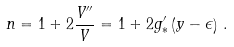<formula> <loc_0><loc_0><loc_500><loc_500>n = 1 + 2 \frac { V ^ { \prime \prime } } { V } = 1 + 2 g ^ { \prime } _ { * } \left ( y - \epsilon \right ) \, .</formula> 